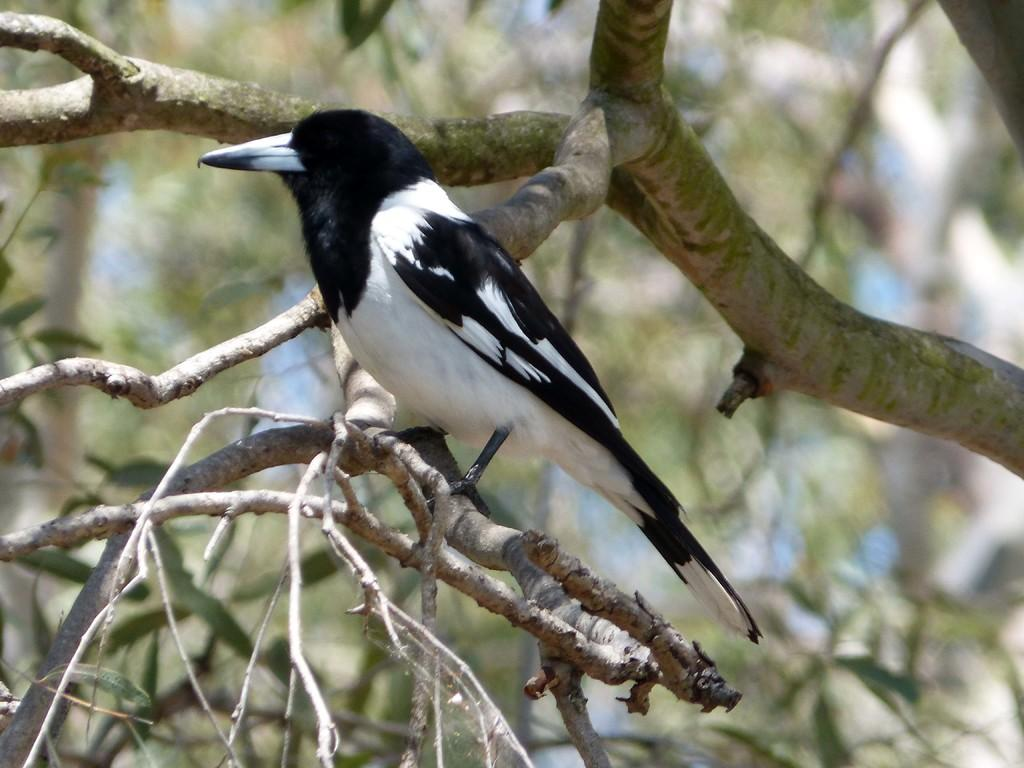What type of animal is in the image? There is a bird in the image. Where is the bird located? The bird is on a tree. What color is the bird in the image? The bird is in black and white color. How would you describe the background of the image? The background of the image is blurred. What type of brass instrument is the bird playing in the image? There is no brass instrument present in the image; it features a bird on a tree in black and white color with a blurred background. 